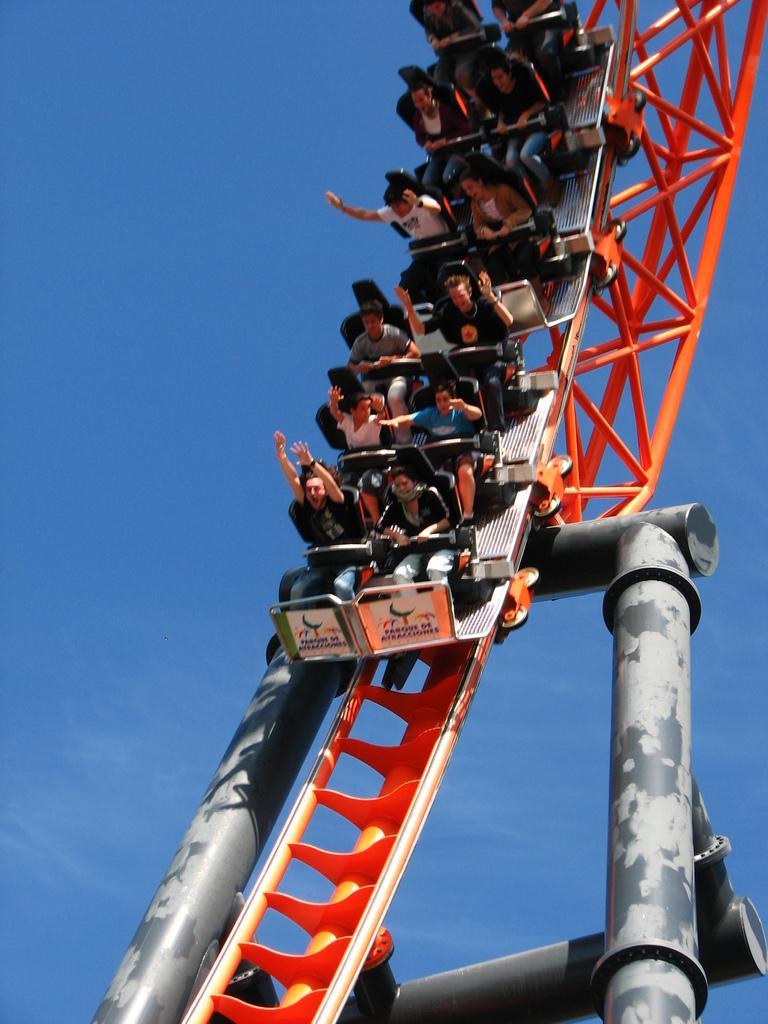Could you give a brief overview of what you see in this image? In the picture we can see a roller coaster with some people sitting on it and behind it we can see a sky. 